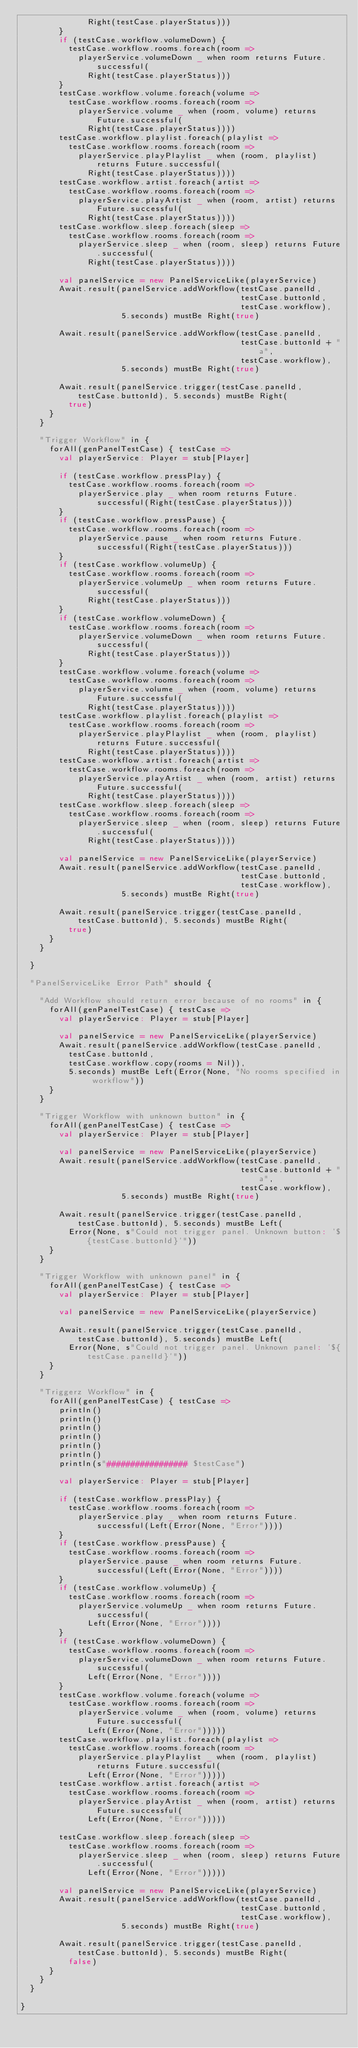<code> <loc_0><loc_0><loc_500><loc_500><_Scala_>              Right(testCase.playerStatus)))
        }
        if (testCase.workflow.volumeDown) {
          testCase.workflow.rooms.foreach(room =>
            playerService.volumeDown _ when room returns Future.successful(
              Right(testCase.playerStatus)))
        }
        testCase.workflow.volume.foreach(volume =>
          testCase.workflow.rooms.foreach(room =>
            playerService.volume _ when (room, volume) returns Future.successful(
              Right(testCase.playerStatus))))
        testCase.workflow.playlist.foreach(playlist =>
          testCase.workflow.rooms.foreach(room =>
            playerService.playPlaylist _ when (room, playlist) returns Future.successful(
              Right(testCase.playerStatus))))
        testCase.workflow.artist.foreach(artist =>
          testCase.workflow.rooms.foreach(room =>
            playerService.playArtist _ when (room, artist) returns Future.successful(
              Right(testCase.playerStatus))))
        testCase.workflow.sleep.foreach(sleep =>
          testCase.workflow.rooms.foreach(room =>
            playerService.sleep _ when (room, sleep) returns Future.successful(
              Right(testCase.playerStatus))))

        val panelService = new PanelServiceLike(playerService)
        Await.result(panelService.addWorkflow(testCase.panelId,
                                              testCase.buttonId,
                                              testCase.workflow),
                     5.seconds) mustBe Right(true)

        Await.result(panelService.addWorkflow(testCase.panelId,
                                              testCase.buttonId + "a",
                                              testCase.workflow),
                     5.seconds) mustBe Right(true)

        Await.result(panelService.trigger(testCase.panelId, testCase.buttonId), 5.seconds) mustBe Right(
          true)
      }
    }

    "Trigger Workflow" in {
      forAll(genPanelTestCase) { testCase =>
        val playerService: Player = stub[Player]

        if (testCase.workflow.pressPlay) {
          testCase.workflow.rooms.foreach(room =>
            playerService.play _ when room returns Future.successful(Right(testCase.playerStatus)))
        }
        if (testCase.workflow.pressPause) {
          testCase.workflow.rooms.foreach(room =>
            playerService.pause _ when room returns Future.successful(Right(testCase.playerStatus)))
        }
        if (testCase.workflow.volumeUp) {
          testCase.workflow.rooms.foreach(room =>
            playerService.volumeUp _ when room returns Future.successful(
              Right(testCase.playerStatus)))
        }
        if (testCase.workflow.volumeDown) {
          testCase.workflow.rooms.foreach(room =>
            playerService.volumeDown _ when room returns Future.successful(
              Right(testCase.playerStatus)))
        }
        testCase.workflow.volume.foreach(volume =>
          testCase.workflow.rooms.foreach(room =>
            playerService.volume _ when (room, volume) returns Future.successful(
              Right(testCase.playerStatus))))
        testCase.workflow.playlist.foreach(playlist =>
          testCase.workflow.rooms.foreach(room =>
            playerService.playPlaylist _ when (room, playlist) returns Future.successful(
              Right(testCase.playerStatus))))
        testCase.workflow.artist.foreach(artist =>
          testCase.workflow.rooms.foreach(room =>
            playerService.playArtist _ when (room, artist) returns Future.successful(
              Right(testCase.playerStatus))))
        testCase.workflow.sleep.foreach(sleep =>
          testCase.workflow.rooms.foreach(room =>
            playerService.sleep _ when (room, sleep) returns Future.successful(
              Right(testCase.playerStatus))))

        val panelService = new PanelServiceLike(playerService)
        Await.result(panelService.addWorkflow(testCase.panelId,
                                              testCase.buttonId,
                                              testCase.workflow),
                     5.seconds) mustBe Right(true)

        Await.result(panelService.trigger(testCase.panelId, testCase.buttonId), 5.seconds) mustBe Right(
          true)
      }
    }

  }

  "PanelServiceLike Error Path" should {

    "Add Workflow should return error because of no rooms" in {
      forAll(genPanelTestCase) { testCase =>
        val playerService: Player = stub[Player]

        val panelService = new PanelServiceLike(playerService)
        Await.result(panelService.addWorkflow(testCase.panelId,
          testCase.buttonId,
          testCase.workflow.copy(rooms = Nil)),
          5.seconds) mustBe Left(Error(None, "No rooms specified in workflow"))
      }
    }

    "Trigger Workflow with unknown button" in {
      forAll(genPanelTestCase) { testCase =>
        val playerService: Player = stub[Player]

        val panelService = new PanelServiceLike(playerService)
        Await.result(panelService.addWorkflow(testCase.panelId,
                                              testCase.buttonId + "a",
                                              testCase.workflow),
                     5.seconds) mustBe Right(true)

        Await.result(panelService.trigger(testCase.panelId, testCase.buttonId), 5.seconds) mustBe Left(
          Error(None, s"Could not trigger panel. Unknown button: '${testCase.buttonId}'"))
      }
    }

    "Trigger Workflow with unknown panel" in {
      forAll(genPanelTestCase) { testCase =>
        val playerService: Player = stub[Player]

        val panelService = new PanelServiceLike(playerService)

        Await.result(panelService.trigger(testCase.panelId, testCase.buttonId), 5.seconds) mustBe Left(
          Error(None, s"Could not trigger panel. Unknown panel: '${testCase.panelId}'"))
      }
    }

    "Triggerz Workflow" in {
      forAll(genPanelTestCase) { testCase =>
        println()
        println()
        println()
        println()
        println()
        println()
        println(s"################# $testCase")

        val playerService: Player = stub[Player]

        if (testCase.workflow.pressPlay) {
          testCase.workflow.rooms.foreach(room =>
            playerService.play _ when room returns Future.successful(Left(Error(None, "Error"))))
        }
        if (testCase.workflow.pressPause) {
          testCase.workflow.rooms.foreach(room =>
            playerService.pause _ when room returns Future.successful(Left(Error(None, "Error"))))
        }
        if (testCase.workflow.volumeUp) {
          testCase.workflow.rooms.foreach(room =>
            playerService.volumeUp _ when room returns Future.successful(
              Left(Error(None, "Error"))))
        }
        if (testCase.workflow.volumeDown) {
          testCase.workflow.rooms.foreach(room =>
            playerService.volumeDown _ when room returns Future.successful(
              Left(Error(None, "Error"))))
        }
        testCase.workflow.volume.foreach(volume =>
          testCase.workflow.rooms.foreach(room =>
            playerService.volume _ when (room, volume) returns Future.successful(
              Left(Error(None, "Error")))))
        testCase.workflow.playlist.foreach(playlist =>
          testCase.workflow.rooms.foreach(room =>
            playerService.playPlaylist _ when (room, playlist) returns Future.successful(
              Left(Error(None, "Error")))))
        testCase.workflow.artist.foreach(artist =>
          testCase.workflow.rooms.foreach(room =>
            playerService.playArtist _ when (room, artist) returns Future.successful(
              Left(Error(None, "Error")))))

        testCase.workflow.sleep.foreach(sleep =>
          testCase.workflow.rooms.foreach(room =>
            playerService.sleep _ when (room, sleep) returns Future.successful(
              Left(Error(None, "Error")))))

        val panelService = new PanelServiceLike(playerService)
        Await.result(panelService.addWorkflow(testCase.panelId,
                                              testCase.buttonId,
                                              testCase.workflow),
                     5.seconds) mustBe Right(true)

        Await.result(panelService.trigger(testCase.panelId, testCase.buttonId), 5.seconds) mustBe Right(
          false)
      }
    }
  }

}
</code> 